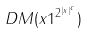<formula> <loc_0><loc_0><loc_500><loc_500>D M ( x 1 ^ { 2 ^ { | x | ^ { c } } } )</formula> 